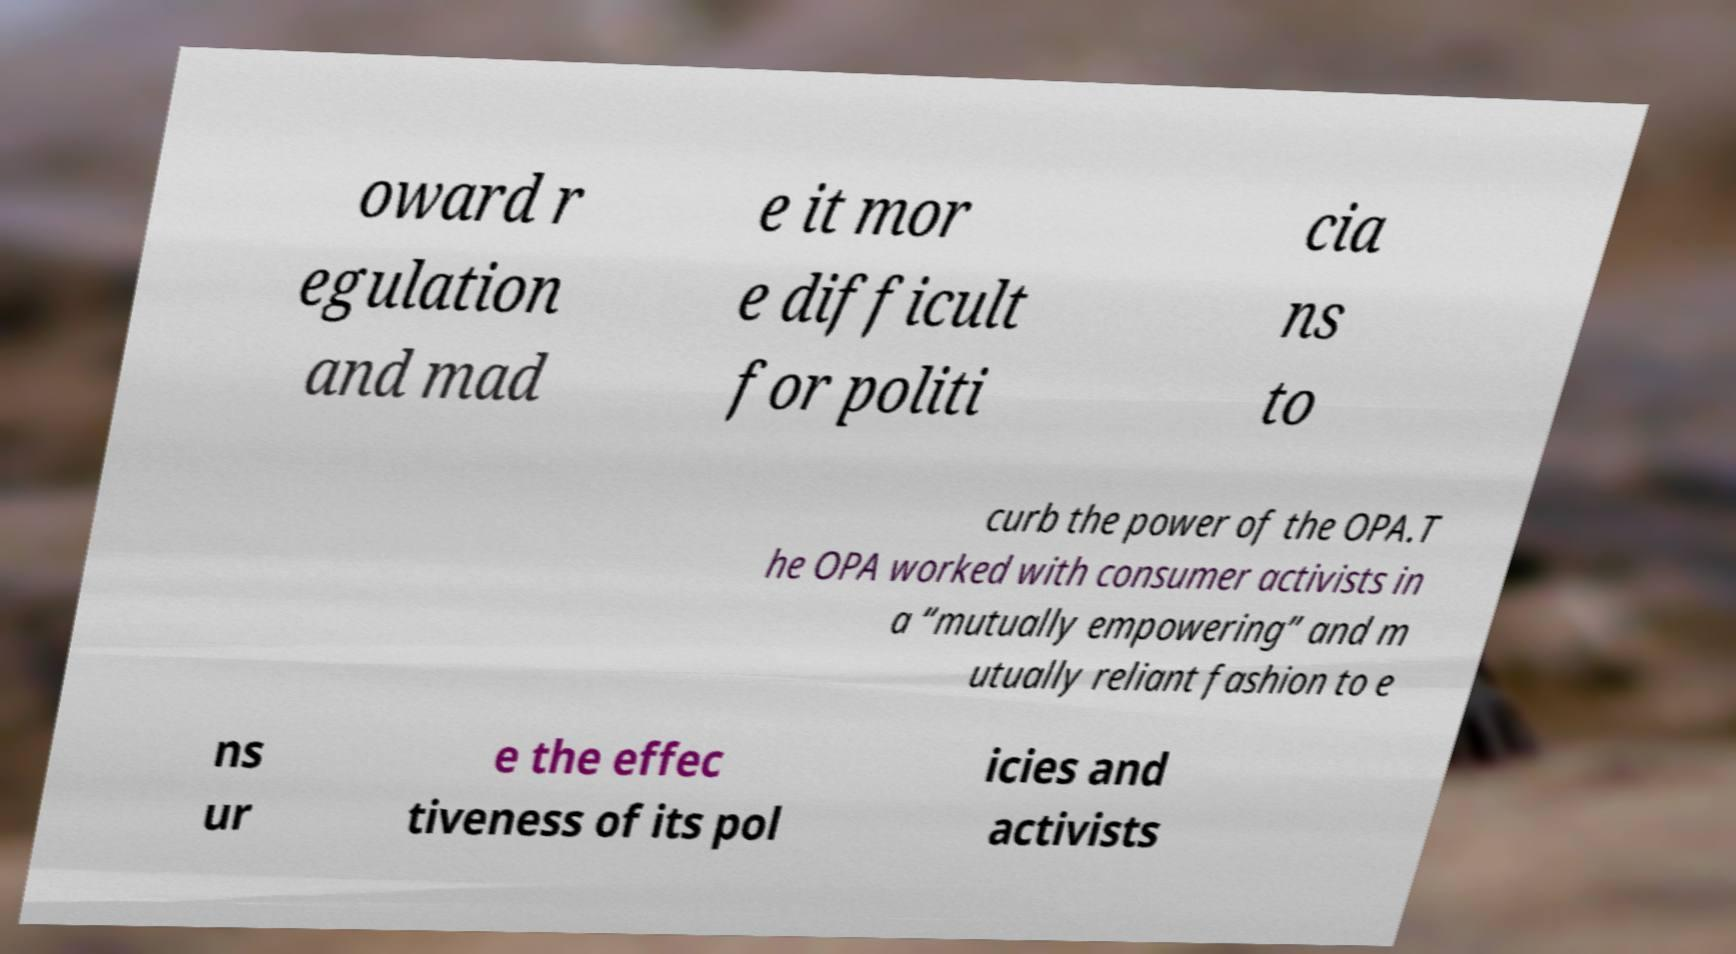Can you read and provide the text displayed in the image?This photo seems to have some interesting text. Can you extract and type it out for me? oward r egulation and mad e it mor e difficult for politi cia ns to curb the power of the OPA.T he OPA worked with consumer activists in a “mutually empowering” and m utually reliant fashion to e ns ur e the effec tiveness of its pol icies and activists 